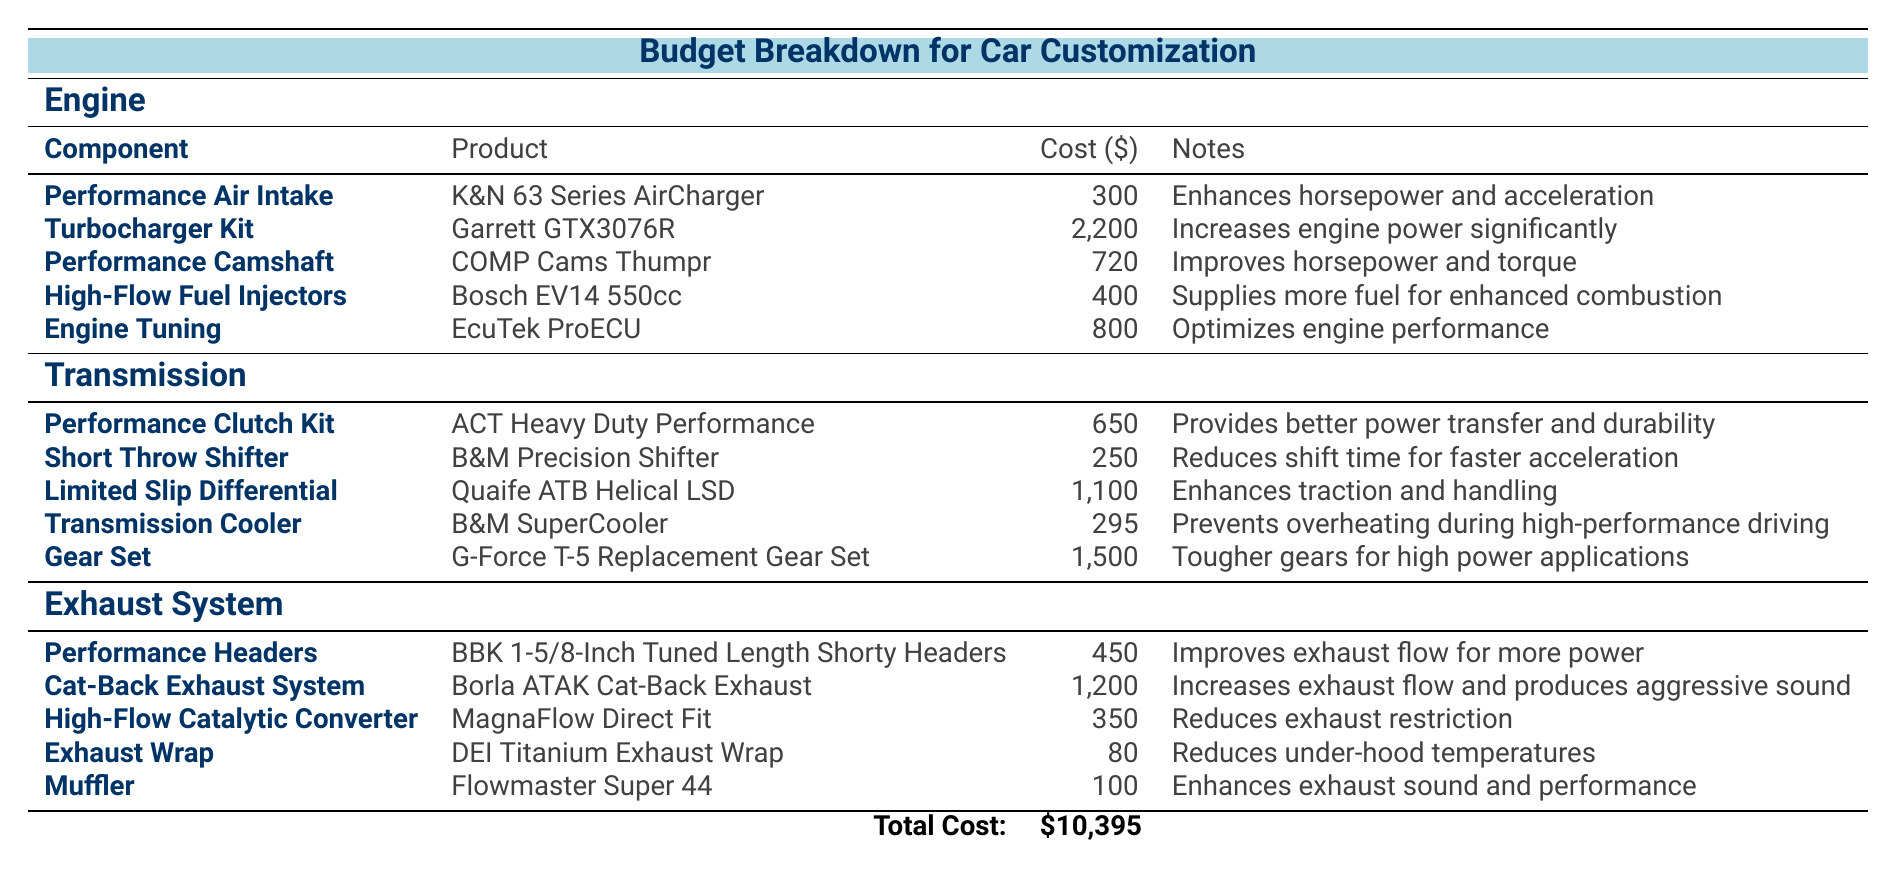What is the cost of the Turbocharger Kit? The Turbocharger Kit is listed in the Engine section of the table with the product name "Garrett GTX3076R," and its cost is stated as 2,200 dollars.
Answer: 2,200 What are the notes for the Performance Headers? The Performance Headers are listed in the Exhaust System section with the product name "BBK 1-5/8-Inch Tuned Length Shorty Headers." The notes indicate that they "improve exhaust flow for more power."
Answer: Improves exhaust flow for more power What is the total cost of customizing the car? The total cost is explicitly stated at the bottom of the table. The total cost of customization for the car is 10,395 dollars.
Answer: 10,395 How much does the High-Flow Fuel Injectors cost compared to the Performance Camshaft? The High-Flow Fuel Injectors cost 400 dollars, and the Performance Camshaft costs 720 dollars. To find the difference, we subtract 400 from 720, which gives us 320 dollars.
Answer: 320 Is the Short Throw Shifter priced below 300 dollars? Referring to the Transmission section, the Short Throw Shifter is listed at 250 dollars. Since this amount is below 300 dollars, the answer is yes.
Answer: Yes What is the total cost of the components listed under the Transmission section? To find the total cost, we add the costs of each item listed in the Transmission section: 650 (Performance Clutch Kit) + 250 (Short Throw Shifter) + 1100 (Limited Slip Differential) + 295 (Transmission Cooler) + 1500 (Gear Set) = 2,795 dollars.
Answer: 2,795 Which component has the highest cost in the Engine section? By reviewing the costs listed in the Engine section: 300 (Performance Air Intake), 2,200 (Turbocharger Kit), 720 (Performance Camshaft), 400 (High-Flow Fuel Injectors), and 800 (Engine Tuning), it is clear that the Turbocharger Kit at 2,200 dollars has the highest cost.
Answer: Turbocharger Kit What is the combined cost of the Cat-Back Exhaust System and Performance Headers? The Cat-Back Exhaust System costs 1,200 dollars and the Performance Headers cost 450 dollars. Adding these together: 1,200 + 450 equals 1,650 dollars.
Answer: 1,650 Would the purchase of the Gear Set and the Limited Slip Differential exceed 2,500 dollars? The Gear Set costs 1,500 dollars, and the Limited Slip Differential costs 1,100 dollars. Adding these gives 1,500 + 1,100 equals 2,600 dollars, which does exceed 2,500 dollars. Therefore, the answer is yes.
Answer: Yes 